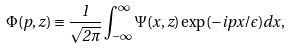Convert formula to latex. <formula><loc_0><loc_0><loc_500><loc_500>\Phi ( p , z ) \equiv \frac { 1 } { \sqrt { 2 \pi } } \int _ { - \infty } ^ { \infty } \Psi ( x , z ) \exp ( - i p x / \epsilon ) d x ,</formula> 